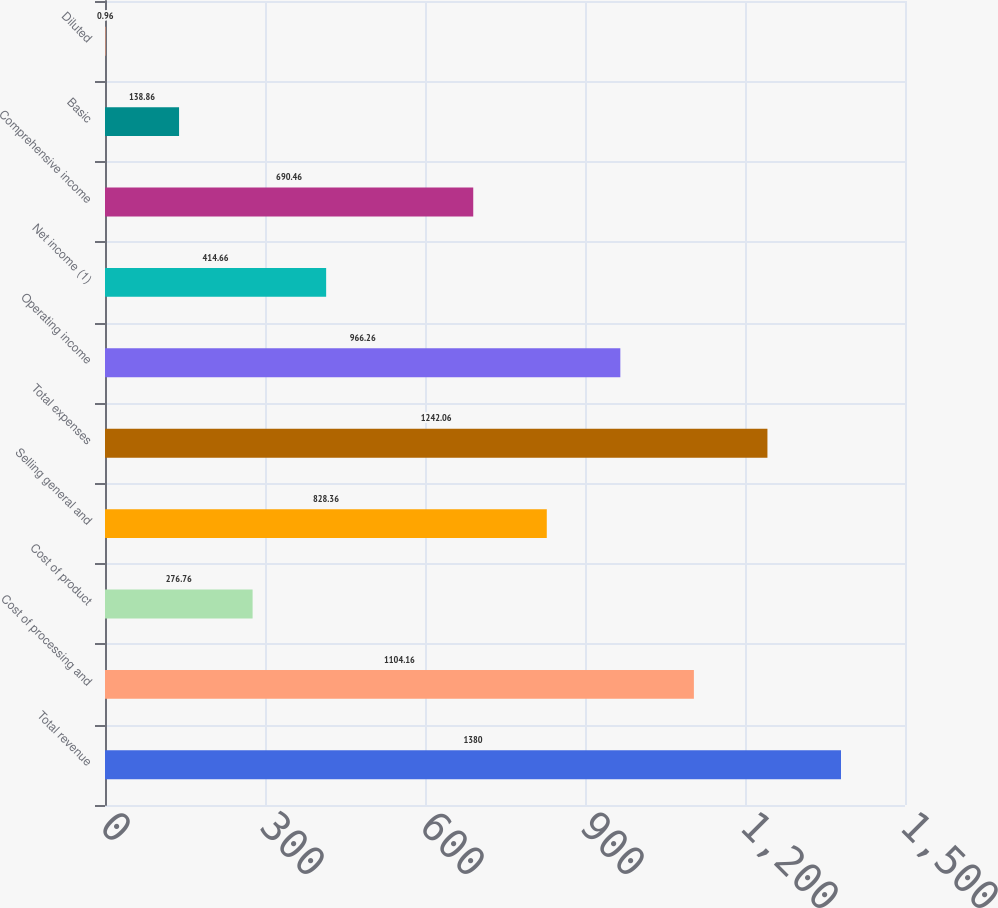Convert chart. <chart><loc_0><loc_0><loc_500><loc_500><bar_chart><fcel>Total revenue<fcel>Cost of processing and<fcel>Cost of product<fcel>Selling general and<fcel>Total expenses<fcel>Operating income<fcel>Net income (1)<fcel>Comprehensive income<fcel>Basic<fcel>Diluted<nl><fcel>1380<fcel>1104.16<fcel>276.76<fcel>828.36<fcel>1242.06<fcel>966.26<fcel>414.66<fcel>690.46<fcel>138.86<fcel>0.96<nl></chart> 